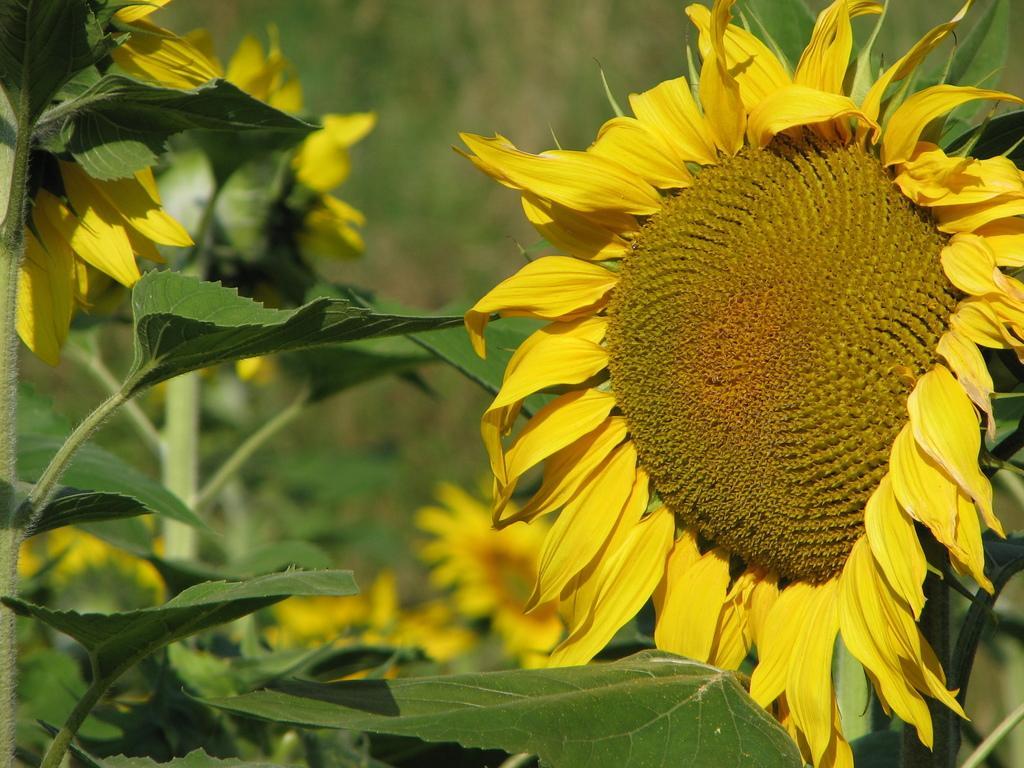Can you describe this image briefly? In this image I see number of planets on which there are flowers which are of yellow and brown in color and I see that it is blurred in the background. 